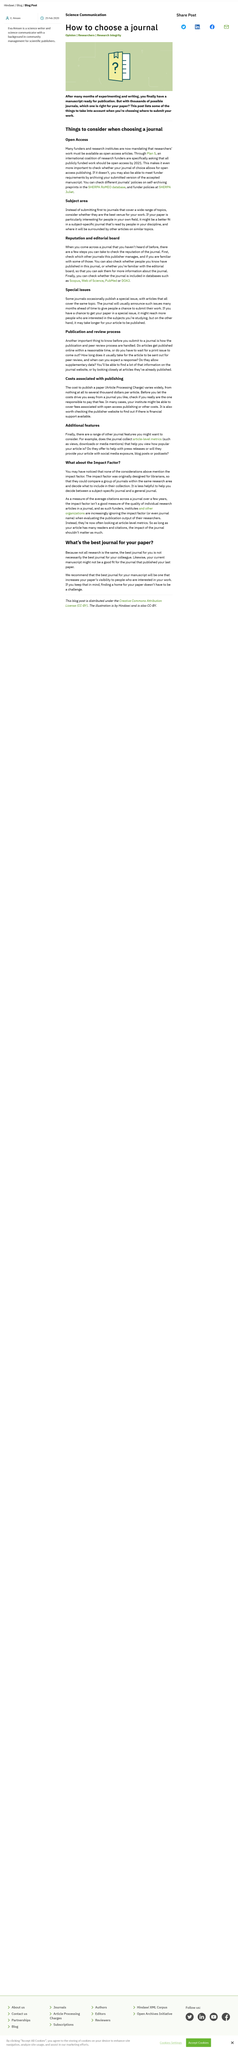Identify some key points in this picture. It is possible to determine the policies of various journals regarding self-archiving preprints by consulting the SHERPA RoMEO database. The costs associated with publishing can vary from nothing to several thousand dollars, depending on a variety of factors. Publishers often provide financial support for authors, and it is prudent to inquire about such support on their website. It is possible for an institute to cover publication fees. Plan S requires that all publicly funded research should be made openly accessible by 2021. 